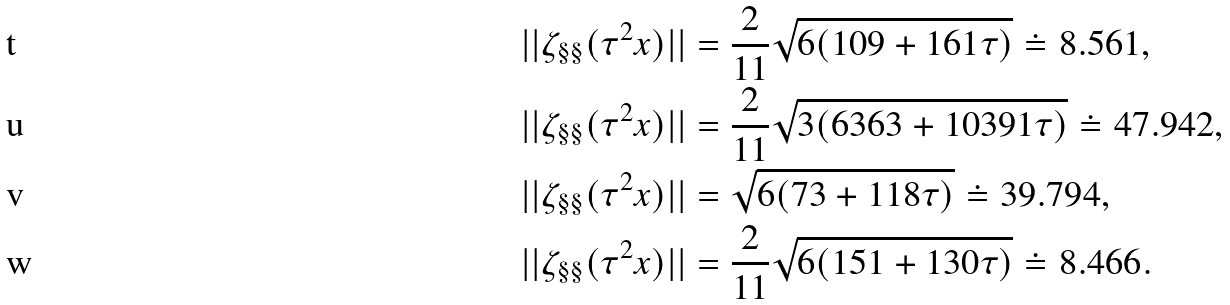Convert formula to latex. <formula><loc_0><loc_0><loc_500><loc_500>| | \zeta _ { \L \L \S \L \S } ( \tau ^ { 2 } x ) | | & = \frac { 2 } { 1 1 } \sqrt { 6 ( 1 0 9 + 1 6 1 \tau ) } \doteq 8 . 5 6 1 , \\ | | \zeta _ { \L \S \L \S \L \L } ( \tau ^ { 2 } x ) | | & = \frac { 2 } { 1 1 } \sqrt { 3 ( 6 3 6 3 + 1 0 3 9 1 \tau ) } \doteq 4 7 . 9 4 2 , \\ | | \zeta _ { \L \S \L \L \S } ( \tau ^ { 2 } x ) | | & = \sqrt { 6 ( 7 3 + 1 1 8 \tau ) } \doteq 3 9 . 7 9 4 , \\ | | \zeta _ { \L \L \S \L \S } ( \tau ^ { 2 } x ) | | & = \frac { 2 } { 1 1 } \sqrt { 6 ( 1 5 1 + 1 3 0 \tau ) } \doteq 8 . 4 6 6 .</formula> 